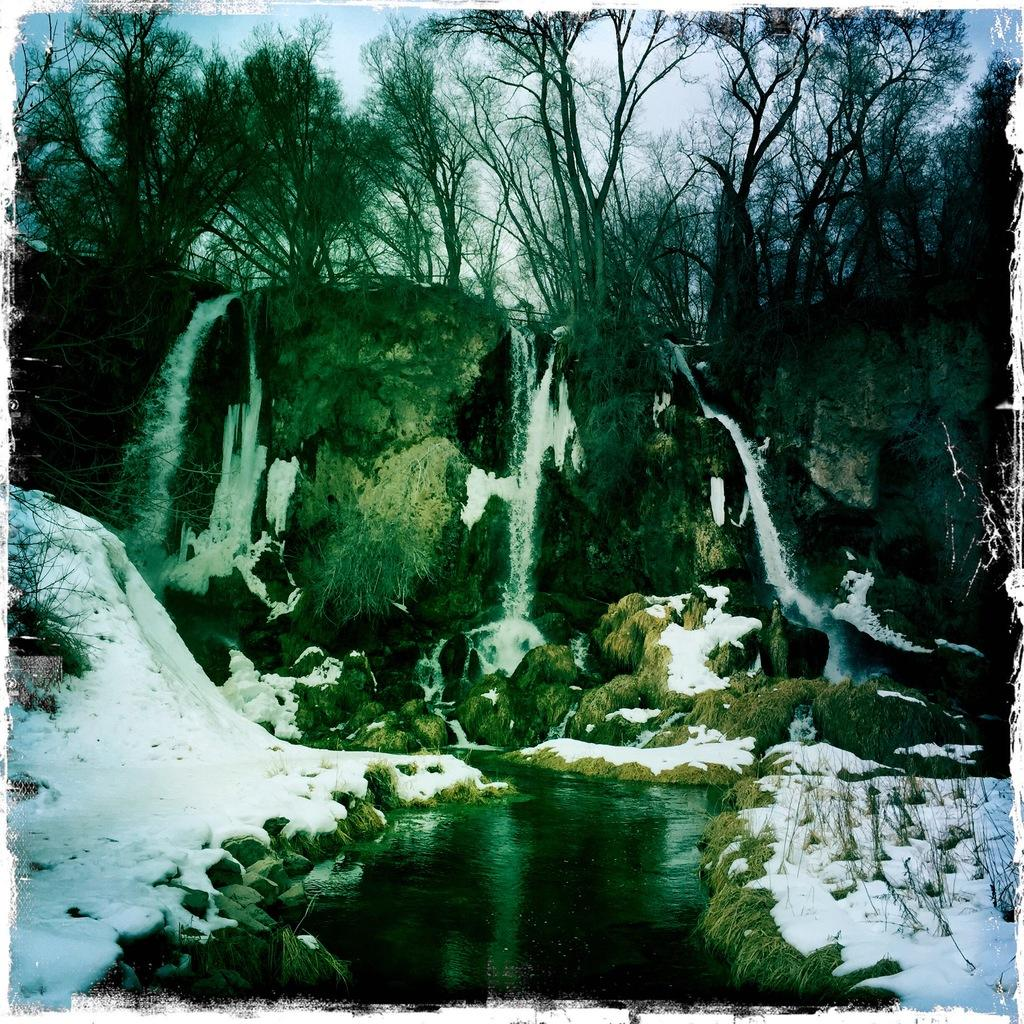What type of natural feature is present in the image? There is a river in the image. What other natural elements can be seen in the image? There are trees in the image. How is the land depicted in the image? The land on both sides of the image is covered with snow. What type of quartz can be seen in the image? There is no quartz present in the image. How does the muscle of the river affect its flow in the image? The image does not depict a river with a muscle, and therefore this aspect cannot be observed. 